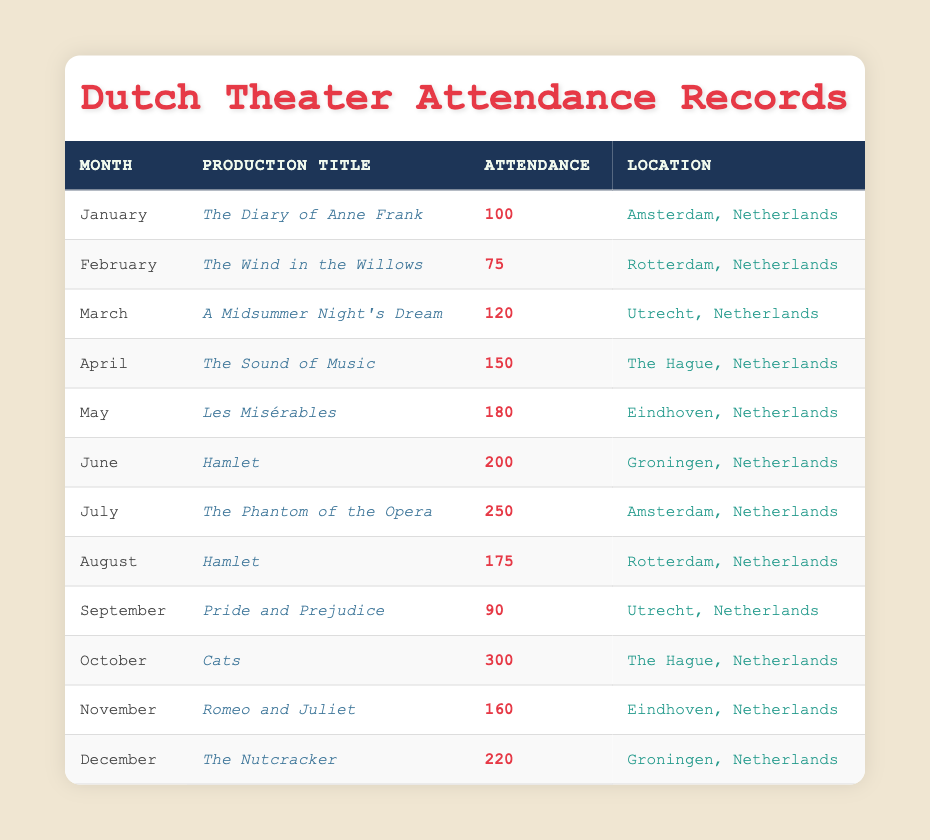What was the attendance for "The Sound of Music"? The table shows that in April, the production titled "The Sound of Music" had an attendance of 150 people.
Answer: 150 Which production had the highest attendance? By examining the attendance numbers in the table, "Cats" in October had the highest attendance with 300 people.
Answer: Cats How many people attended "Hamlet" in June and August combined? The attendance for "Hamlet" in June was 200 and in August was 175. Therefore, the total attendance for both months is 200 + 175 = 375.
Answer: 375 True or False: "Pride and Prejudice" had more attendance than "The Diary of Anne Frank." "Pride and Prejudice" had an attendance of 90, while "The Diary of Anne Frank" had 100 attendees. Since 90 is less than 100, the statement is false.
Answer: False What is the average attendance for all productions held in Rotterdam? The productions held in Rotterdam are "The Wind in the Willows" (75) in February and "Hamlet" (175) in August. The average is calculated as (75 + 175) / 2 = 125.
Answer: 125 Which month had the lowest attendance and what was the count? In February, the production "The Wind in the Willows" had the lowest attendance of 75.
Answer: February, 75 How many more attendees were there in October compared to April? In October, attendance for "Cats" was 300, and in April for "The Sound of Music" it was 150. The difference is 300 - 150 = 150.
Answer: 150 Was the attendance in May higher than in September? In May, attendance for "Les Misérables" was 180, while in September for "Pride and Prejudice," it was 90. Since 180 is greater than 90, the answer is yes.
Answer: Yes What is the total attendance for the productions in Groningen? The productions in Groningen are "Hamlet" (200) in June and "The Nutcracker" (220) in December. The total attendance is 200 + 220 = 420.
Answer: 420 Which production had attendance in the range of 100 to 200? From the table, "A Midsummer Night's Dream" with 120 and "The Sound of Music" with 150 both fall within this range, suggesting they are valid answers.
Answer: A Midsummer Night's Dream, The Sound of Music 